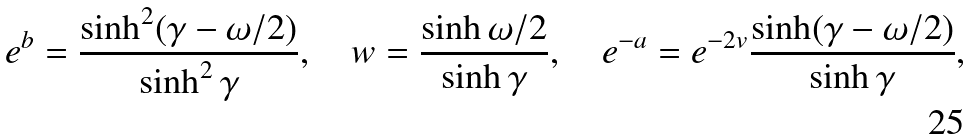Convert formula to latex. <formula><loc_0><loc_0><loc_500><loc_500>e ^ { b } = \frac { \sinh ^ { 2 } ( \gamma - \omega / 2 ) } { \sinh ^ { 2 } \gamma } , \quad w = \frac { \sinh \omega / 2 } { \sinh \gamma } , \quad e ^ { - a } = e ^ { - 2 v } \frac { \sinh ( \gamma - \omega / 2 ) } { \sinh \gamma } ,</formula> 